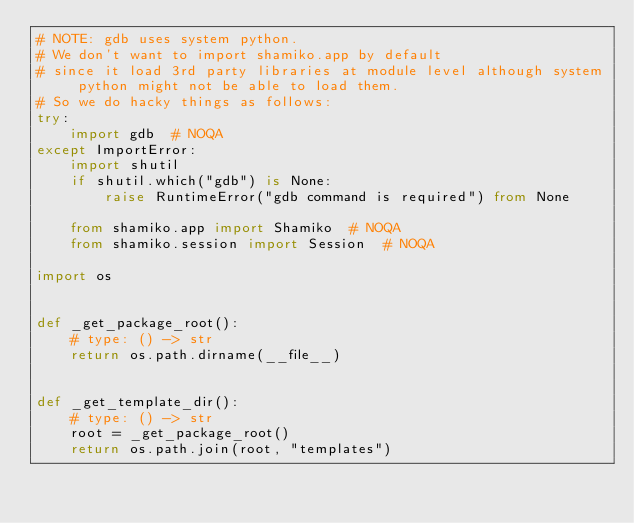<code> <loc_0><loc_0><loc_500><loc_500><_Python_># NOTE: gdb uses system python.
# We don't want to import shamiko.app by default
# since it load 3rd party libraries at module level although system python might not be able to load them.
# So we do hacky things as follows:
try:
    import gdb  # NOQA
except ImportError:
    import shutil
    if shutil.which("gdb") is None:
        raise RuntimeError("gdb command is required") from None

    from shamiko.app import Shamiko  # NOQA
    from shamiko.session import Session  # NOQA

import os


def _get_package_root():
    # type: () -> str
    return os.path.dirname(__file__)


def _get_template_dir():
    # type: () -> str
    root = _get_package_root()
    return os.path.join(root, "templates")
</code> 